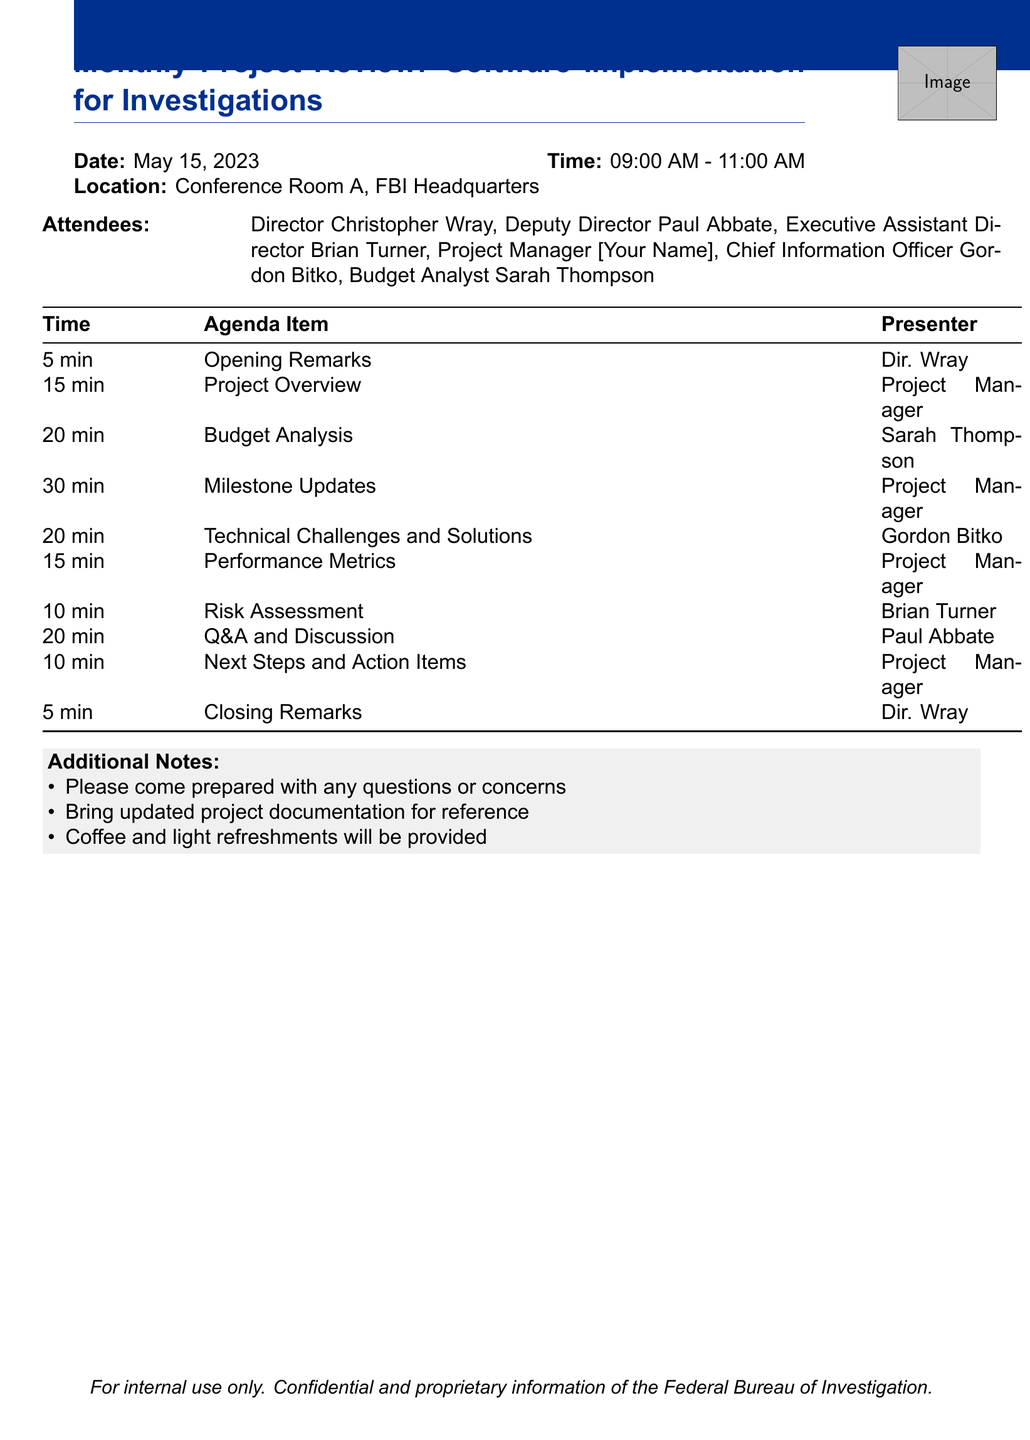What is the title of the meeting? The title of the meeting is stated in the header of the document.
Answer: Monthly Project Review: Software Implementation for Investigations What is the date of the meeting? The date is mentioned alongside the title of the meeting.
Answer: May 15, 2023 Who is presenting the Budget Analysis? The presenter is indicated in the agenda item section related to budget analysis.
Answer: Budget Analyst Sarah Thompson How long is the Milestone Updates presentation scheduled to last? The duration is clearly specified next to the Milestone Updates in the agenda.
Answer: 30 minutes What is the total duration of the meeting? The start and end time give an indication of the total duration of the meeting, which can be calculated.
Answer: 2 hours How many attendees are listed in the document? The number of attendees is specified in the attendees section.
Answer: 6 What is the primary focus of the Performance Metrics presentation? The key points for this presentation outline the specific focus areas mentioned in the agenda.
Answer: Key Performance Indicators (KPIs) for the IDA tool What additional materials should participants bring? The additional notes section indicates what participants should prepare for the meeting.
Answer: Updated project documentation Who is facilitating the Q&A and Discussion segment? The facilitator is clearly identified in the agenda item for Q&A and Discussion.
Answer: Deputy Director Paul Abbate 